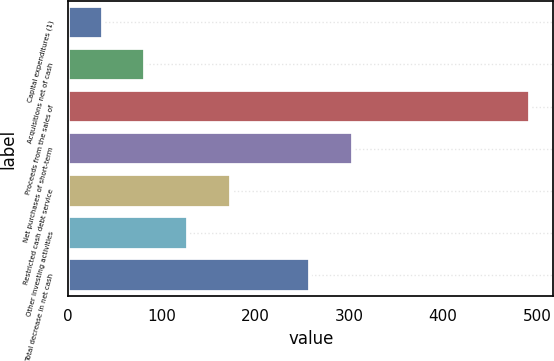Convert chart to OTSL. <chart><loc_0><loc_0><loc_500><loc_500><bar_chart><fcel>Capital expenditures (1)<fcel>Acquisitions net of cash<fcel>Proceeds from the sales of<fcel>Net purchases of short-term<fcel>Restricted cash debt service<fcel>Other investing activities<fcel>Total decrease in net cash<nl><fcel>37<fcel>82.6<fcel>493<fcel>303.6<fcel>173.8<fcel>128.2<fcel>258<nl></chart> 